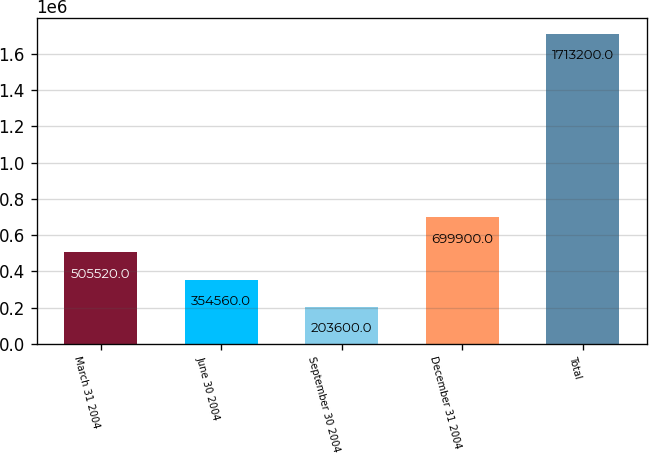<chart> <loc_0><loc_0><loc_500><loc_500><bar_chart><fcel>March 31 2004<fcel>June 30 2004<fcel>September 30 2004<fcel>December 31 2004<fcel>Total<nl><fcel>505520<fcel>354560<fcel>203600<fcel>699900<fcel>1.7132e+06<nl></chart> 